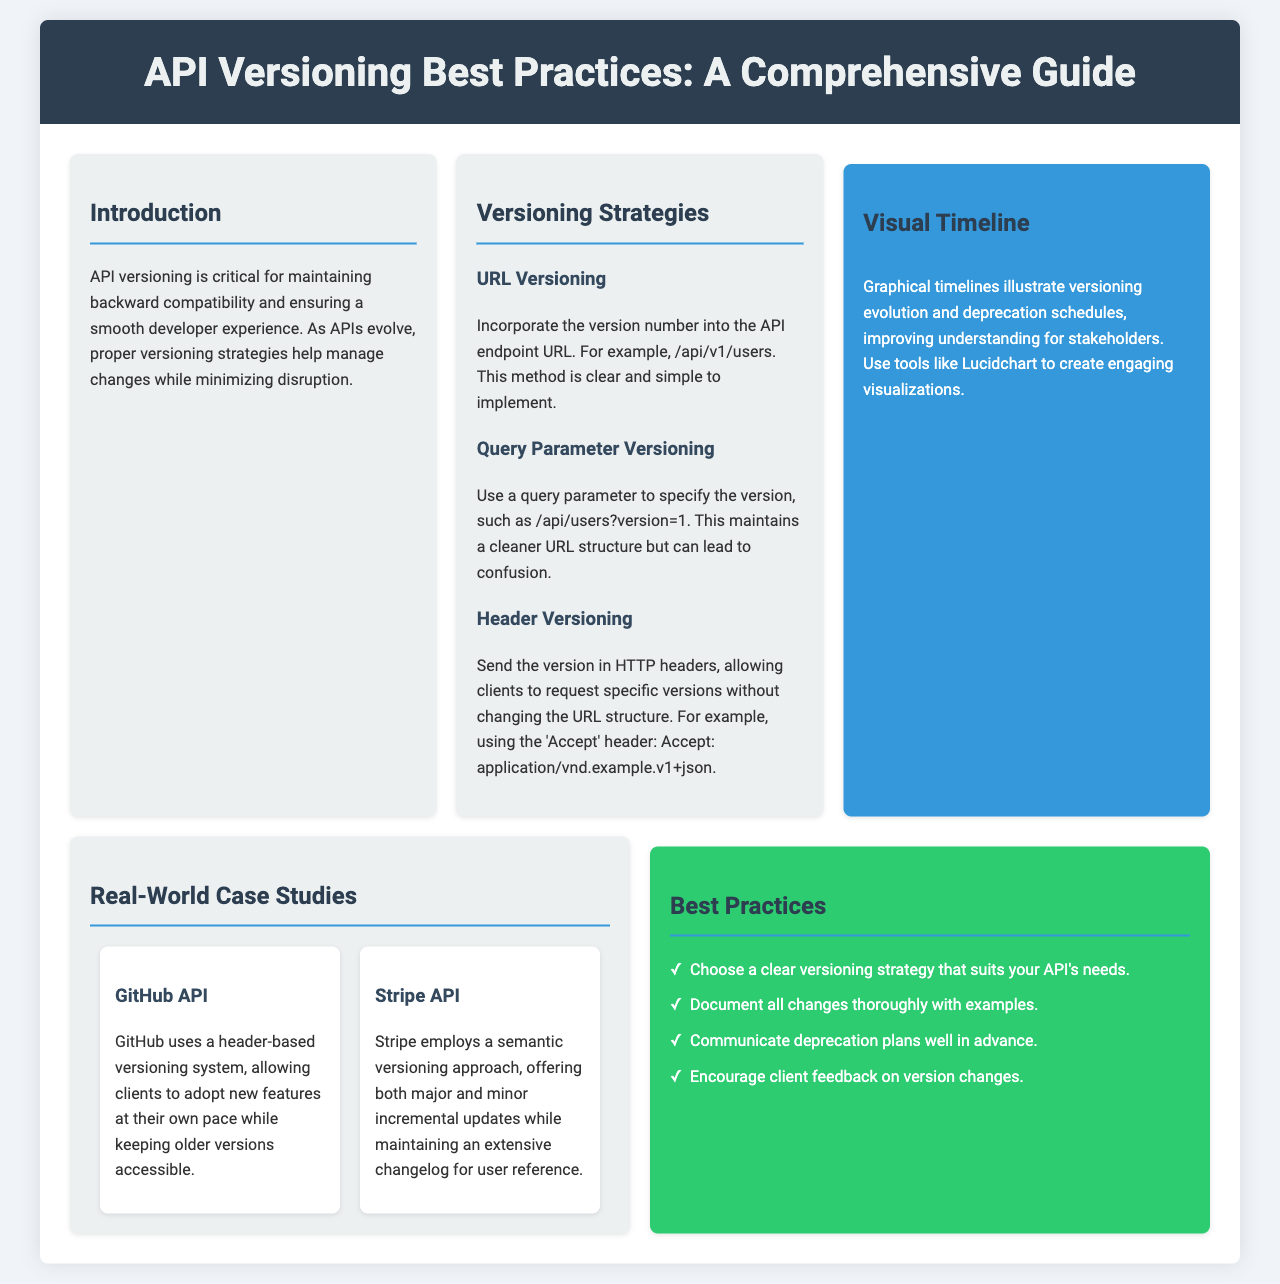What is the title of the brochure? The title of the brochure is prominently displayed at the top.
Answer: API Versioning Best Practices: A Comprehensive Guide What is one method of versioning mentioned? The document lists various methods of versioning under a specific section.
Answer: URL Versioning Which API uses a header-based versioning system? The real-world case studies section provides examples of APIs and their versioning systems.
Answer: GitHub API How many real-world case studies are presented? The section on real-world case studies contains multiple examples.
Answer: Two What color is the best practices section? The color scheme of sections is specified in the document's style, which indicates background colors.
Answer: Green What should communication about deprecation plans be? The best practices section outlines key recommendations for effective API management.
Answer: Well in advance What is recommended for client feedback? The best practices provide a suggestion regarding engaging with clients during version changes.
Answer: Encourage client feedback on version changes What visualization tool is suggested for timelines? The document recommends a specific tool in the visual timeline section.
Answer: Lucidchart 